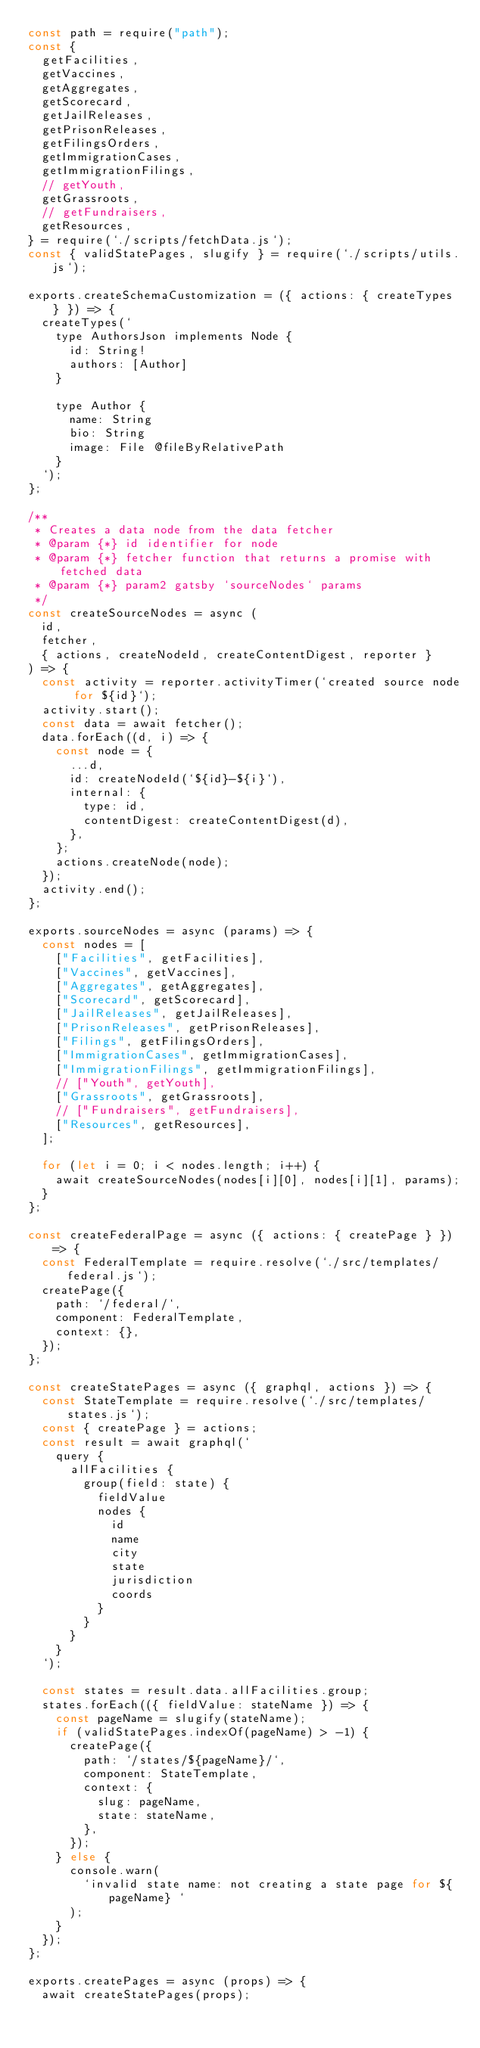<code> <loc_0><loc_0><loc_500><loc_500><_JavaScript_>const path = require("path");
const {
  getFacilities,
  getVaccines,
  getAggregates,
  getScorecard,
  getJailReleases,
  getPrisonReleases,
  getFilingsOrders,
  getImmigrationCases,
  getImmigrationFilings,
  // getYouth,
  getGrassroots,
  // getFundraisers,
  getResources,
} = require(`./scripts/fetchData.js`);
const { validStatePages, slugify } = require(`./scripts/utils.js`);

exports.createSchemaCustomization = ({ actions: { createTypes } }) => {
  createTypes(`
    type AuthorsJson implements Node {
      id: String!
      authors: [Author]
    }

    type Author {
      name: String
      bio: String
      image: File @fileByRelativePath
    }
  `);
};

/**
 * Creates a data node from the data fetcher
 * @param {*} id identifier for node
 * @param {*} fetcher function that returns a promise with fetched data
 * @param {*} param2 gatsby `sourceNodes` params
 */
const createSourceNodes = async (
  id,
  fetcher,
  { actions, createNodeId, createContentDigest, reporter }
) => {
  const activity = reporter.activityTimer(`created source node for ${id}`);
  activity.start();
  const data = await fetcher();
  data.forEach((d, i) => {
    const node = {
      ...d,
      id: createNodeId(`${id}-${i}`),
      internal: {
        type: id,
        contentDigest: createContentDigest(d),
      },
    };
    actions.createNode(node);
  });
  activity.end();
};

exports.sourceNodes = async (params) => {
  const nodes = [
    ["Facilities", getFacilities],
    ["Vaccines", getVaccines],
    ["Aggregates", getAggregates],
    ["Scorecard", getScorecard],
    ["JailReleases", getJailReleases],
    ["PrisonReleases", getPrisonReleases],
    ["Filings", getFilingsOrders],
    ["ImmigrationCases", getImmigrationCases],
    ["ImmigrationFilings", getImmigrationFilings],
    // ["Youth", getYouth],
    ["Grassroots", getGrassroots],
    // ["Fundraisers", getFundraisers],
    ["Resources", getResources],
  ];

  for (let i = 0; i < nodes.length; i++) {
    await createSourceNodes(nodes[i][0], nodes[i][1], params);
  }
};

const createFederalPage = async ({ actions: { createPage } }) => {
  const FederalTemplate = require.resolve(`./src/templates/federal.js`);
  createPage({
    path: `/federal/`,
    component: FederalTemplate,
    context: {},
  });
};

const createStatePages = async ({ graphql, actions }) => {
  const StateTemplate = require.resolve(`./src/templates/states.js`);
  const { createPage } = actions;
  const result = await graphql(`
    query {
      allFacilities {
        group(field: state) {
          fieldValue
          nodes {
            id
            name
            city
            state
            jurisdiction
            coords
          }
        }
      }
    }
  `);

  const states = result.data.allFacilities.group;
  states.forEach(({ fieldValue: stateName }) => {
    const pageName = slugify(stateName);
    if (validStatePages.indexOf(pageName) > -1) {
      createPage({
        path: `/states/${pageName}/`,
        component: StateTemplate,
        context: {
          slug: pageName,
          state: stateName,
        },
      });
    } else {
      console.warn(
        `invalid state name: not creating a state page for ${pageName} `
      );
    }
  });
};

exports.createPages = async (props) => {
  await createStatePages(props);</code> 